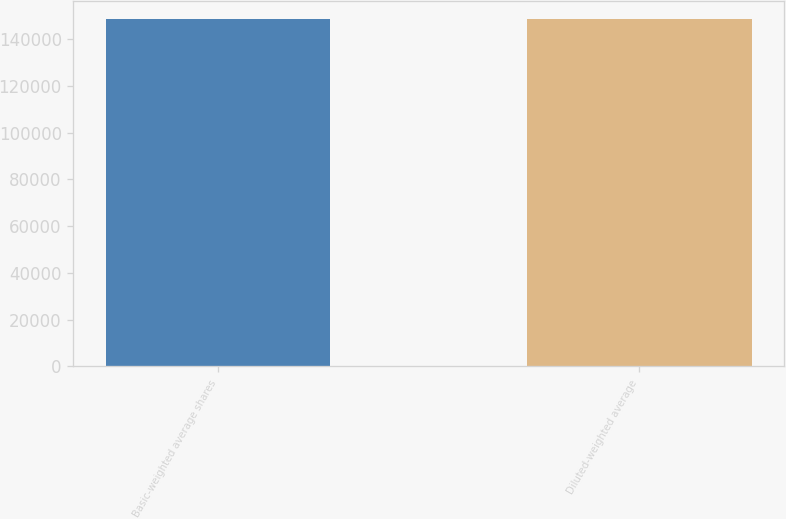Convert chart to OTSL. <chart><loc_0><loc_0><loc_500><loc_500><bar_chart><fcel>Basic-weighted average shares<fcel>Diluted-weighted average<nl><fcel>148831<fcel>148831<nl></chart> 